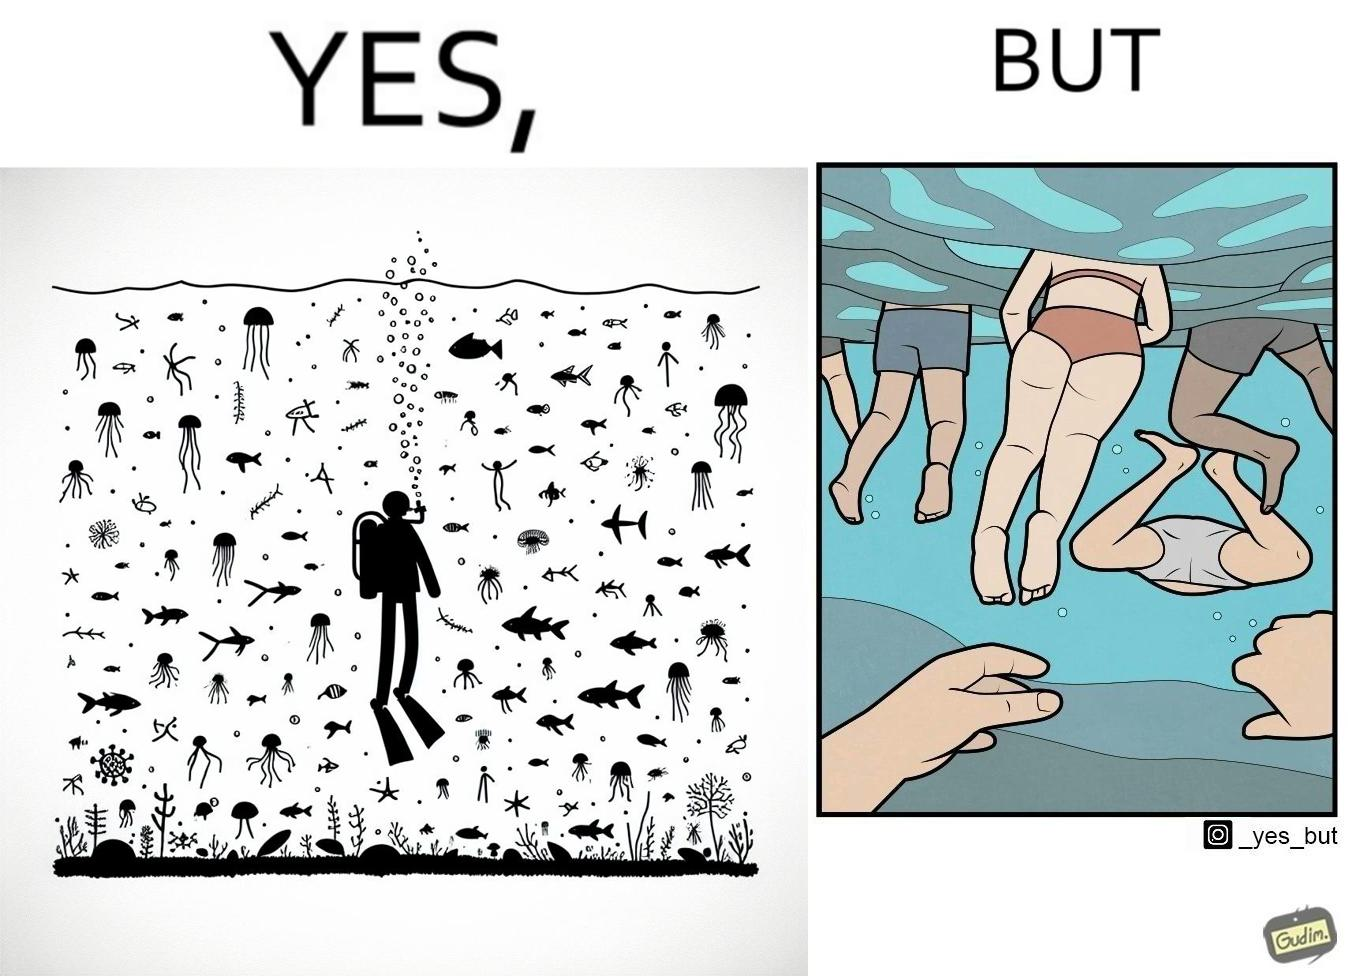Explain the humor or irony in this image. The image is ironic, because some people like to enjoy watching the biodiversity under water but they are not able to explore this due to excess crowd in such places where people like to play, swim etc. in water 